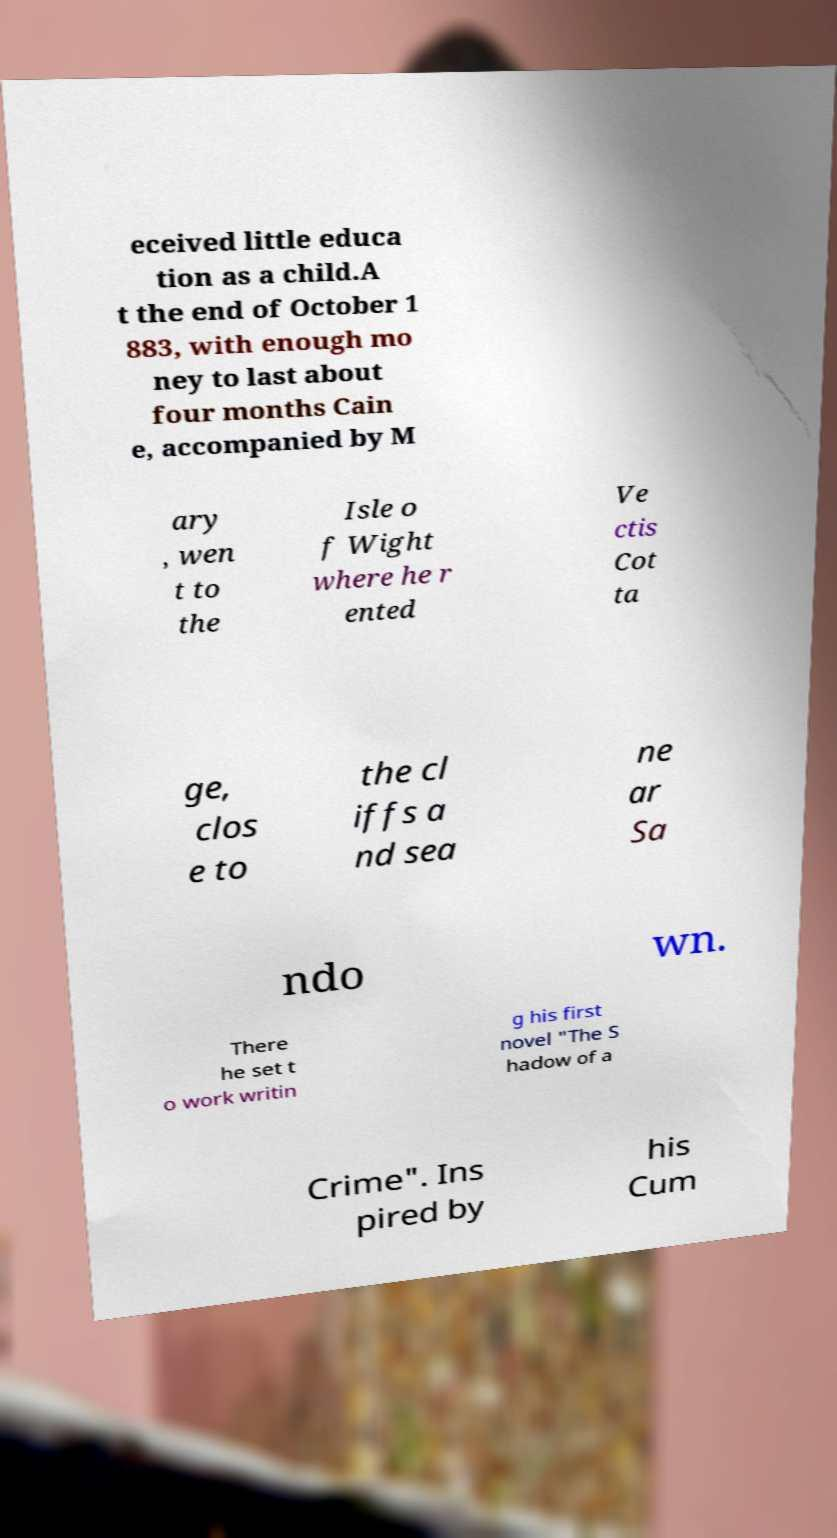Please read and relay the text visible in this image. What does it say? eceived little educa tion as a child.A t the end of October 1 883, with enough mo ney to last about four months Cain e, accompanied by M ary , wen t to the Isle o f Wight where he r ented Ve ctis Cot ta ge, clos e to the cl iffs a nd sea ne ar Sa ndo wn. There he set t o work writin g his first novel "The S hadow of a Crime". Ins pired by his Cum 